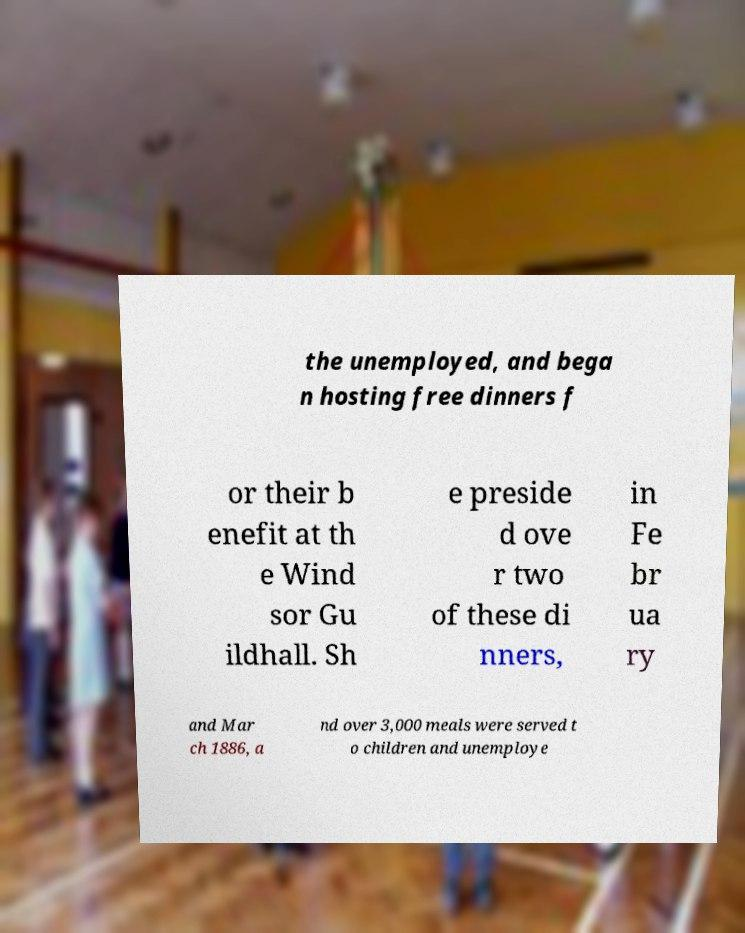Could you assist in decoding the text presented in this image and type it out clearly? the unemployed, and bega n hosting free dinners f or their b enefit at th e Wind sor Gu ildhall. Sh e preside d ove r two of these di nners, in Fe br ua ry and Mar ch 1886, a nd over 3,000 meals were served t o children and unemploye 